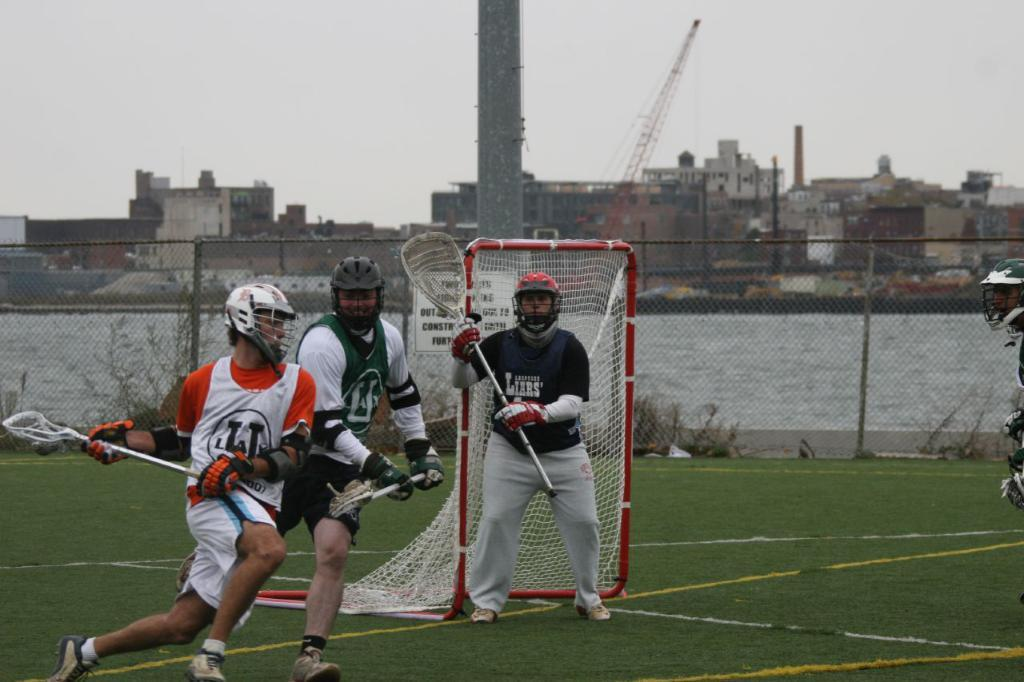What is the main activity of the persons in the image? The persons in the image are on the grass, which suggests they might be engaged in an outdoor activity. What can be seen in the background of the image? In the background of the image, there is a net, fencing, water, buildings, a pillar, and the sky. How many distinct structures or elements can be seen in the background of the image? There are at least seven distinct structures or elements visible in the background of the image. What type of bead is being used by the persons in the image? There is no bead present in the image. 